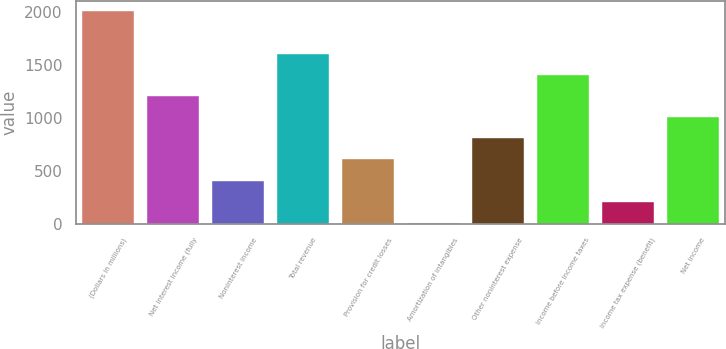<chart> <loc_0><loc_0><loc_500><loc_500><bar_chart><fcel>(Dollars in millions)<fcel>Net interest income (fully<fcel>Noninterest income<fcel>Total revenue<fcel>Provision for credit losses<fcel>Amortization of intangibles<fcel>Other noninterest expense<fcel>Income before income taxes<fcel>Income tax expense (benefit)<fcel>Net income<nl><fcel>2003<fcel>1203.8<fcel>404.6<fcel>1603.4<fcel>604.4<fcel>5<fcel>804.2<fcel>1403.6<fcel>204.8<fcel>1004<nl></chart> 